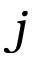<formula> <loc_0><loc_0><loc_500><loc_500>j</formula> 